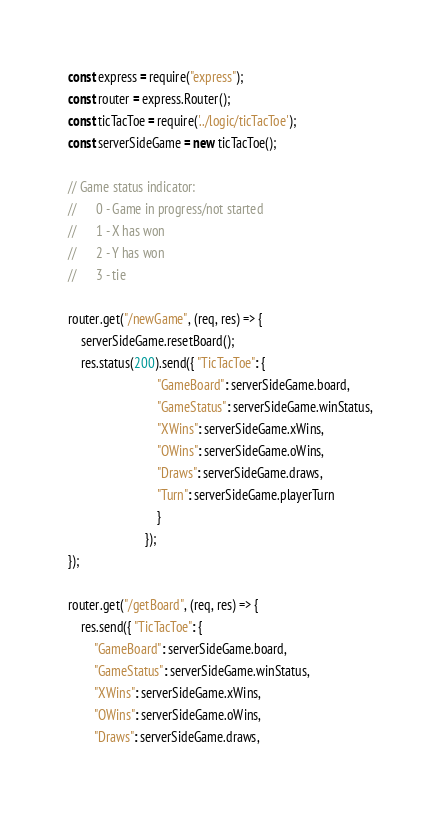<code> <loc_0><loc_0><loc_500><loc_500><_JavaScript_>const express = require("express");
const router = express.Router();
const ticTacToe = require('../logic/ticTacToe');
const serverSideGame = new ticTacToe();

// Game status indicator:
//      0 - Game in progress/not started
//      1 - X has won
//      2 - Y has won
//      3 - tie

router.get("/newGame", (req, res) => {
    serverSideGame.resetBoard();
    res.status(200).send({ "TicTacToe": {
                            "GameBoard": serverSideGame.board,
                            "GameStatus": serverSideGame.winStatus,
                            "XWins": serverSideGame.xWins,
                            "OWins": serverSideGame.oWins,
                            "Draws": serverSideGame.draws,
                            "Turn": serverSideGame.playerTurn
                            }
                        });
});
  
router.get("/getBoard", (req, res) => {
    res.send({ "TicTacToe": {
        "GameBoard": serverSideGame.board,
        "GameStatus": serverSideGame.winStatus,
        "XWins": serverSideGame.xWins,
        "OWins": serverSideGame.oWins,
        "Draws": serverSideGame.draws,</code> 